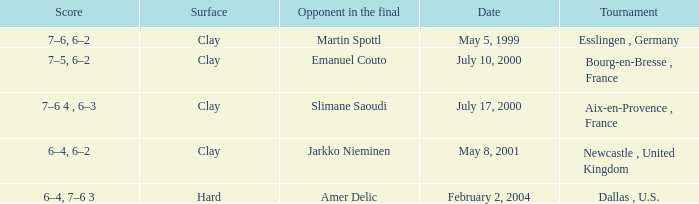What is the Score of the Tournament with Opponent in the final of Martin Spottl? 7–6, 6–2. 